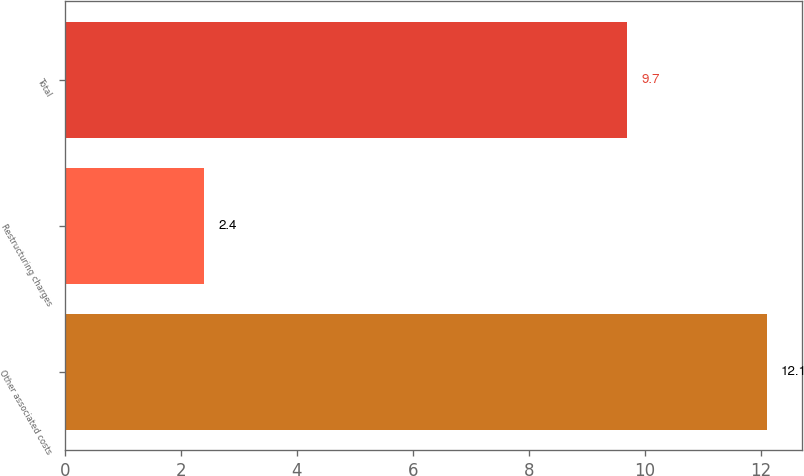Convert chart to OTSL. <chart><loc_0><loc_0><loc_500><loc_500><bar_chart><fcel>Other associated costs<fcel>Restructuring charges<fcel>Total<nl><fcel>12.1<fcel>2.4<fcel>9.7<nl></chart> 